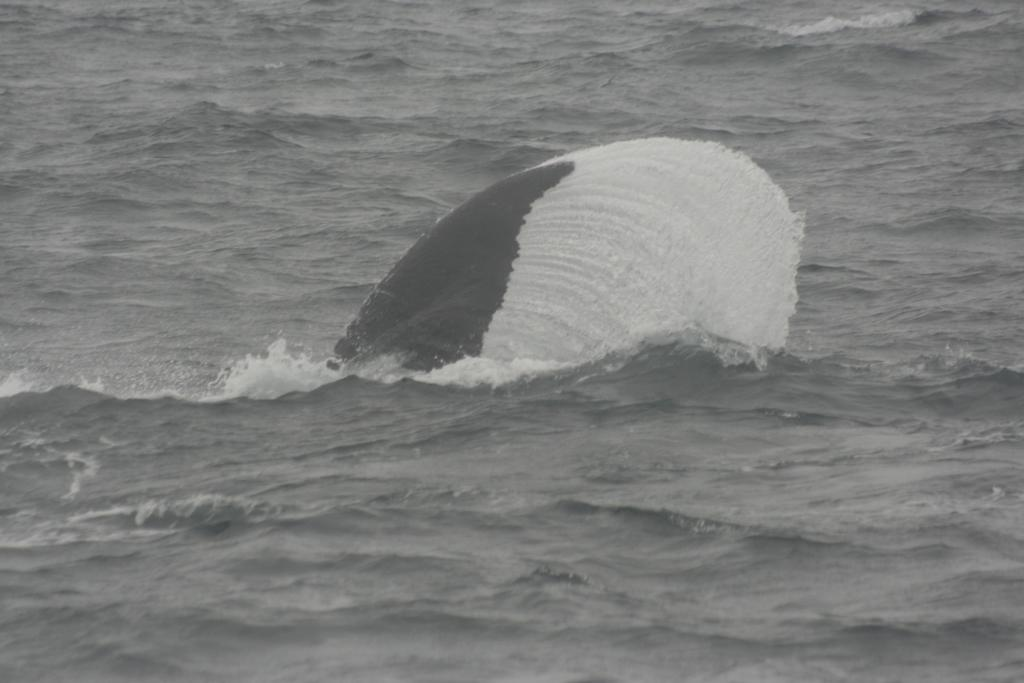What is visible in the water in the image? There is a fishtail in the water in the image. What type of grass is growing near the wound in the image? There is no grass or wound present in the image; it only features a fishtail in the water. 